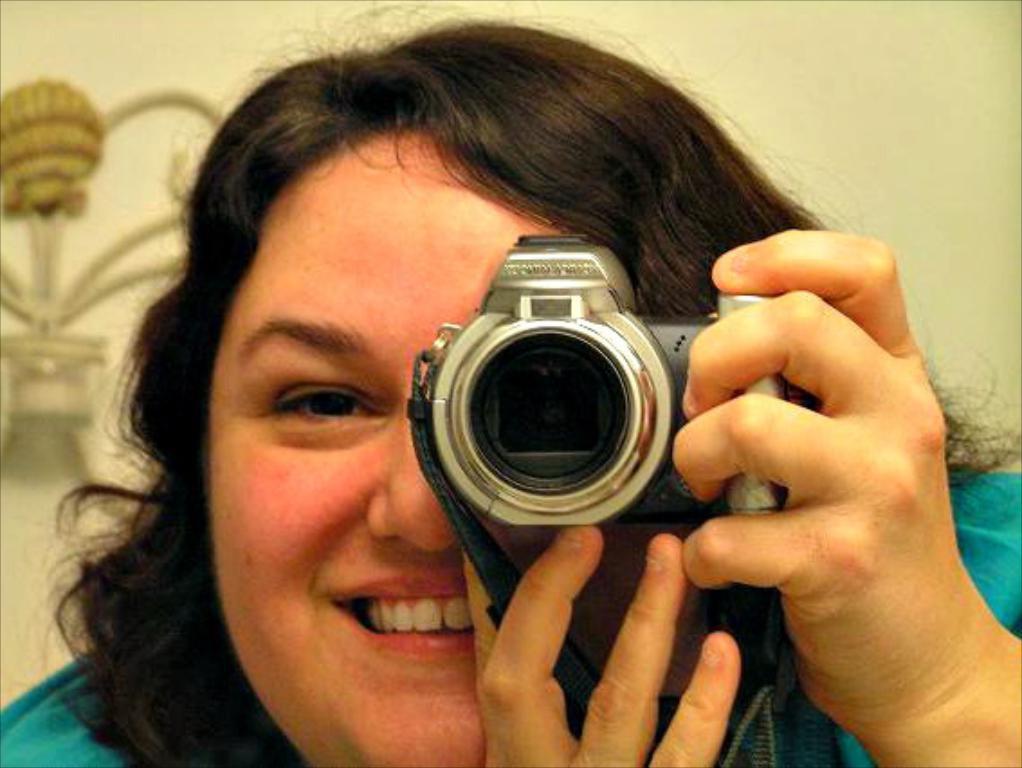Describe this image in one or two sentences. In this picture we can see a woman holding a camera with her hand and smiling and in the background we can see an object on the wall. 